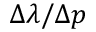<formula> <loc_0><loc_0><loc_500><loc_500>\Delta \lambda / \Delta p</formula> 